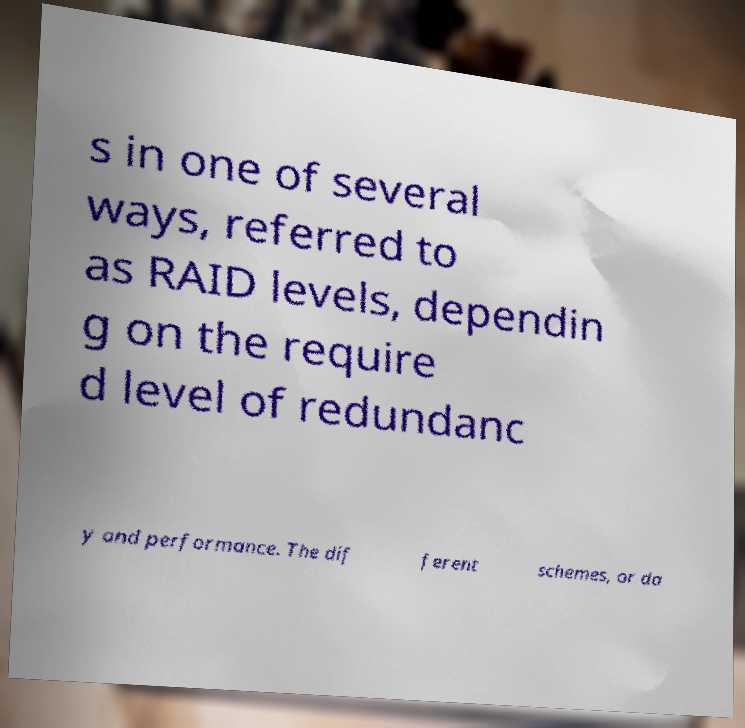Could you extract and type out the text from this image? s in one of several ways, referred to as RAID levels, dependin g on the require d level of redundanc y and performance. The dif ferent schemes, or da 